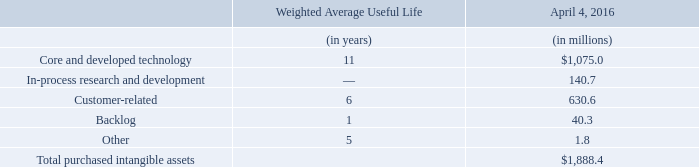Purchased Intangible Assets
Purchased intangible assets include core and developed technology, in-process research and development, customer-related intangibles, acquisition-date backlog and other intangible assets. The estimated fair values of the core and developed technology and in-process research and development were determined based on the present value of the expected cash flows to be generated by the respective existing technology or future technology. The core and developed technology intangible assets are being amortized in a manner based on the expected cash flows used in the initial determination of fair value. In-process research and development is capitalized until such time as the related projects are completed or abandoned at which time the capitalized amounts will begin to be amortized or written off. Customer-related intangible assets consist of Atmel's contractual relationships and customer loyalty related to its distributor and end-customer relationships, and the fair values of the customerrelated intangibles were determined based on Atmel's projected revenues. An analysis of expected attrition and revenue growth for existing customers was prepared from Atmel's historical customer information. Customer relationships are being amortized in a manner based on the estimated cash flows associated with the existing customers and anticipated retention rates. Backlog relates to the value of orders not yet shipped by Atmel at the acquisition date, and the fair values were based on the estimated profit associated with those orders. Backlog related assets had a one year useful life and were being amortized on a straight line basis over that period. The total weighted average amortization period of intangible assets acquired as a result of the Atmel transaction is 9 years. Amortization expense associated with acquired intangible assets is not deductible for tax purposes. Thus, approximately $178.1 million was established as a net deferred tax liability for the future amortization of the intangible assets.
What did purchased intangible assets include? Core and developed technology, in-process research and development, customer-related intangibles, acquisition-date backlog and other intangible assets. How was the stimated fair values of the core and developed technology and in-process research and development determined? Based on the present value of the expected cash flows to be generated by the respective existing technology or future technology. What was the amount of core and developed technology?
Answer scale should be: million. 1,075.0. What was the difference in Weighted Average Useful Life between Core and developed technology and customer-related assets? 11-6
Answer: 5. What was the sum of the amount of Core and developed technology and in-process research and development assets?
Answer scale should be: million. 1,075.0+140.7
Answer: 1215.7. What was the Core and developed technology assets as a percentage of Total purchased intangible assets?
Answer scale should be: percent. 1,075.0/1,888.4
Answer: 56.93. 